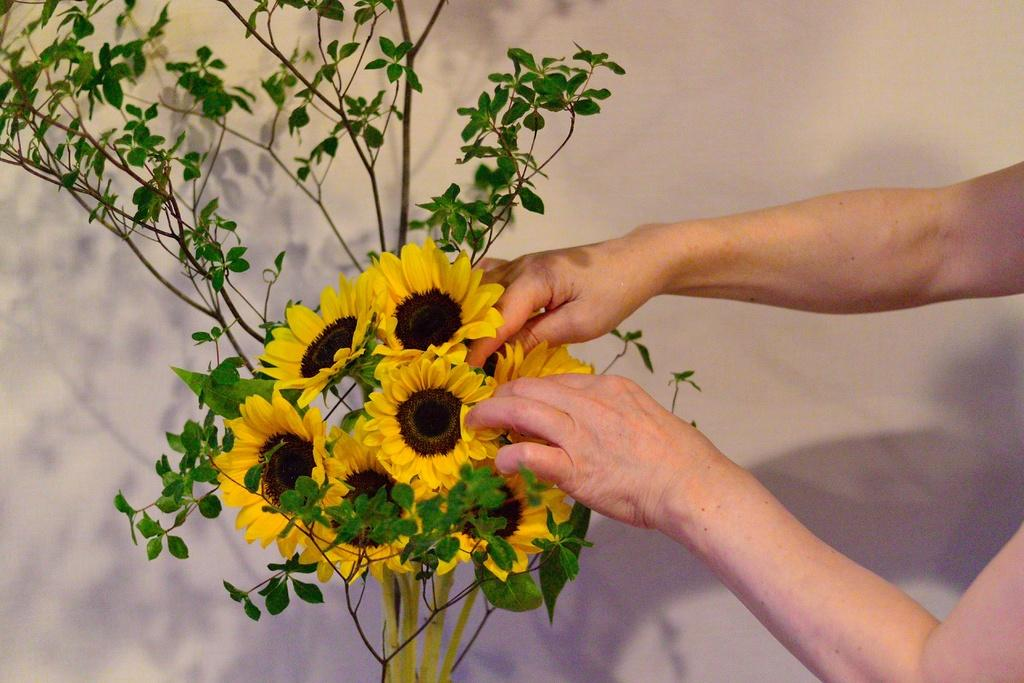What is present in the image? There is a plant in the image. Can you describe the plant's appearance? The plant has yellow flowers. What is the person's hand doing in relation to the plant? A person's hand is holding the plant. How does the plant transport itself to different locations in the image? The plant does not transport itself in the image; it is stationary and being held by a person's hand. 